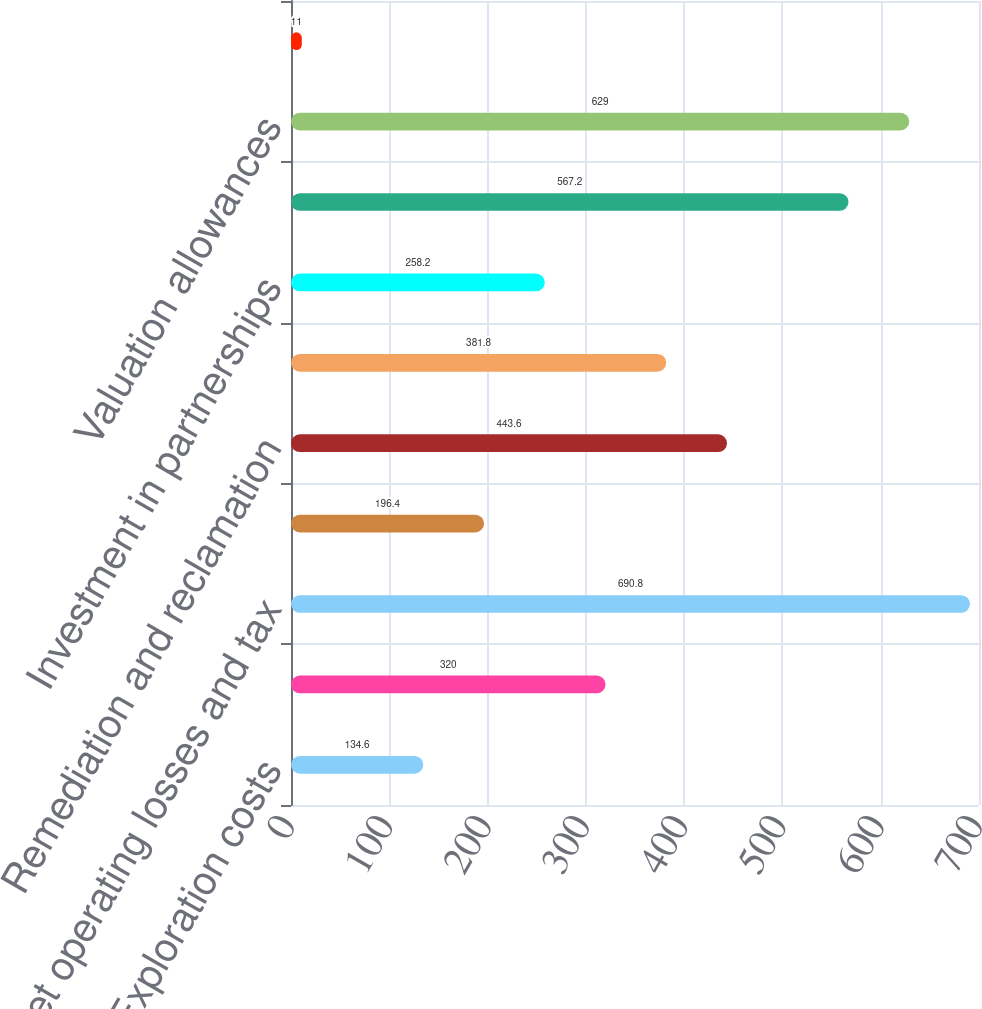Convert chart to OTSL. <chart><loc_0><loc_0><loc_500><loc_500><bar_chart><fcel>Exploration costs<fcel>Depreciation<fcel>Net operating losses and tax<fcel>Retiree benefit and vacation<fcel>Remediation and reclamation<fcel>Derivative instruments<fcel>Investment in partnerships<fcel>Other<fcel>Valuation allowances<fcel>Net undistributed earnings of<nl><fcel>134.6<fcel>320<fcel>690.8<fcel>196.4<fcel>443.6<fcel>381.8<fcel>258.2<fcel>567.2<fcel>629<fcel>11<nl></chart> 